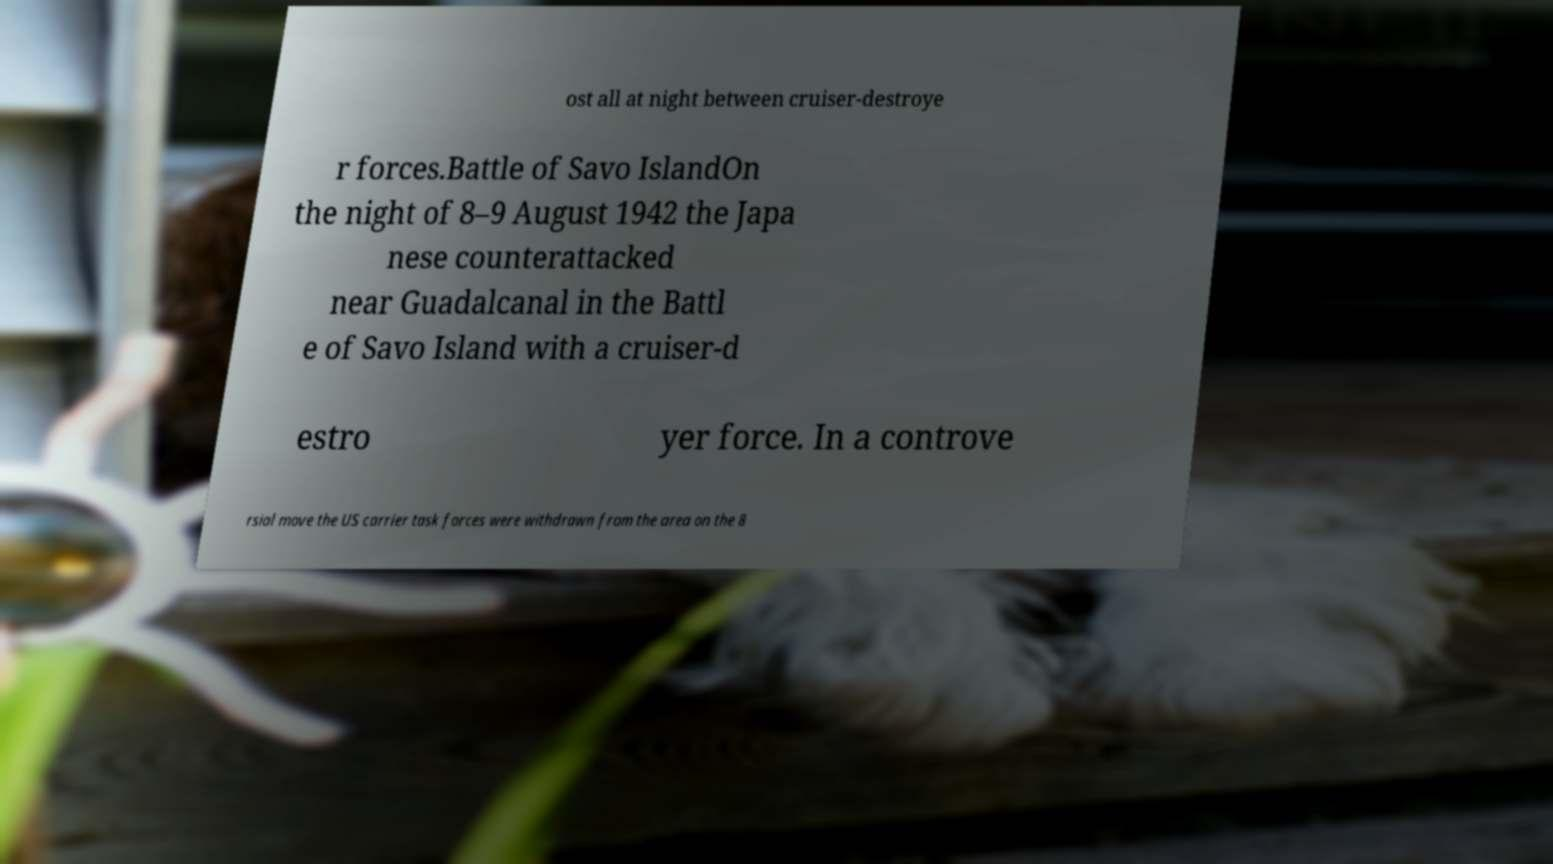I need the written content from this picture converted into text. Can you do that? ost all at night between cruiser-destroye r forces.Battle of Savo IslandOn the night of 8–9 August 1942 the Japa nese counterattacked near Guadalcanal in the Battl e of Savo Island with a cruiser-d estro yer force. In a controve rsial move the US carrier task forces were withdrawn from the area on the 8 